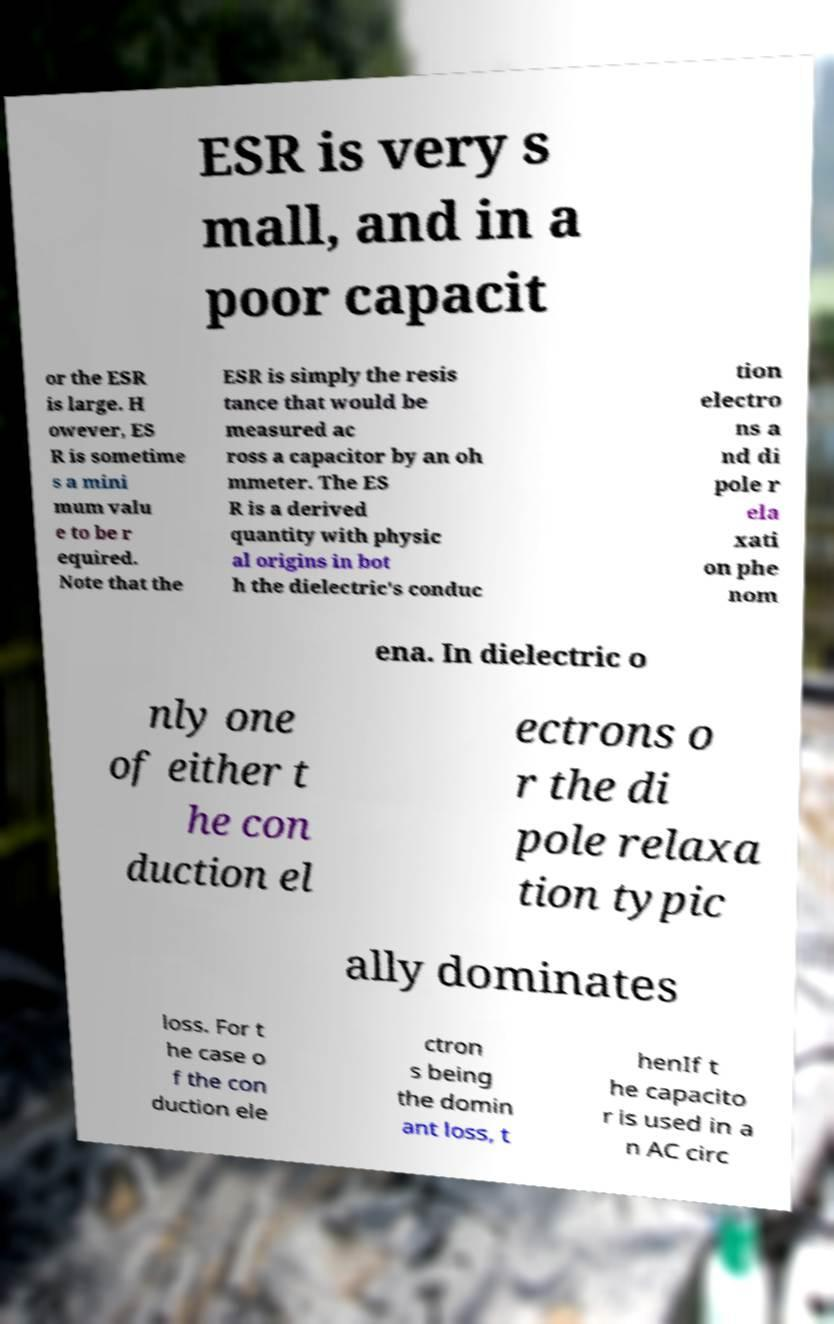I need the written content from this picture converted into text. Can you do that? ESR is very s mall, and in a poor capacit or the ESR is large. H owever, ES R is sometime s a mini mum valu e to be r equired. Note that the ESR is simply the resis tance that would be measured ac ross a capacitor by an oh mmeter. The ES R is a derived quantity with physic al origins in bot h the dielectric's conduc tion electro ns a nd di pole r ela xati on phe nom ena. In dielectric o nly one of either t he con duction el ectrons o r the di pole relaxa tion typic ally dominates loss. For t he case o f the con duction ele ctron s being the domin ant loss, t henIf t he capacito r is used in a n AC circ 